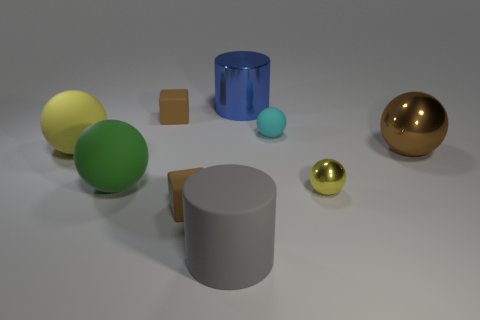What shape is the thing that is the same color as the tiny metal sphere?
Keep it short and to the point. Sphere. The big brown thing that is made of the same material as the small yellow thing is what shape?
Provide a short and direct response. Sphere. What is the color of the large shiny sphere?
Make the answer very short. Brown. Are there any small brown blocks behind the yellow sphere that is on the right side of the big gray rubber thing?
Give a very brief answer. Yes. What number of matte objects have the same size as the brown ball?
Your answer should be compact. 3. There is a small brown block behind the tiny matte thing that is to the right of the large gray rubber cylinder; what number of shiny spheres are behind it?
Offer a very short reply. 0. What number of big things are both to the left of the brown metal ball and to the right of the cyan rubber thing?
Provide a succinct answer. 0. Is there any other thing of the same color as the large metal ball?
Provide a short and direct response. Yes. What number of rubber objects are green things or large cylinders?
Your answer should be very brief. 2. What is the material of the yellow thing that is to the right of the large matte thing that is on the right side of the brown matte cube in front of the brown metallic thing?
Provide a short and direct response. Metal. 